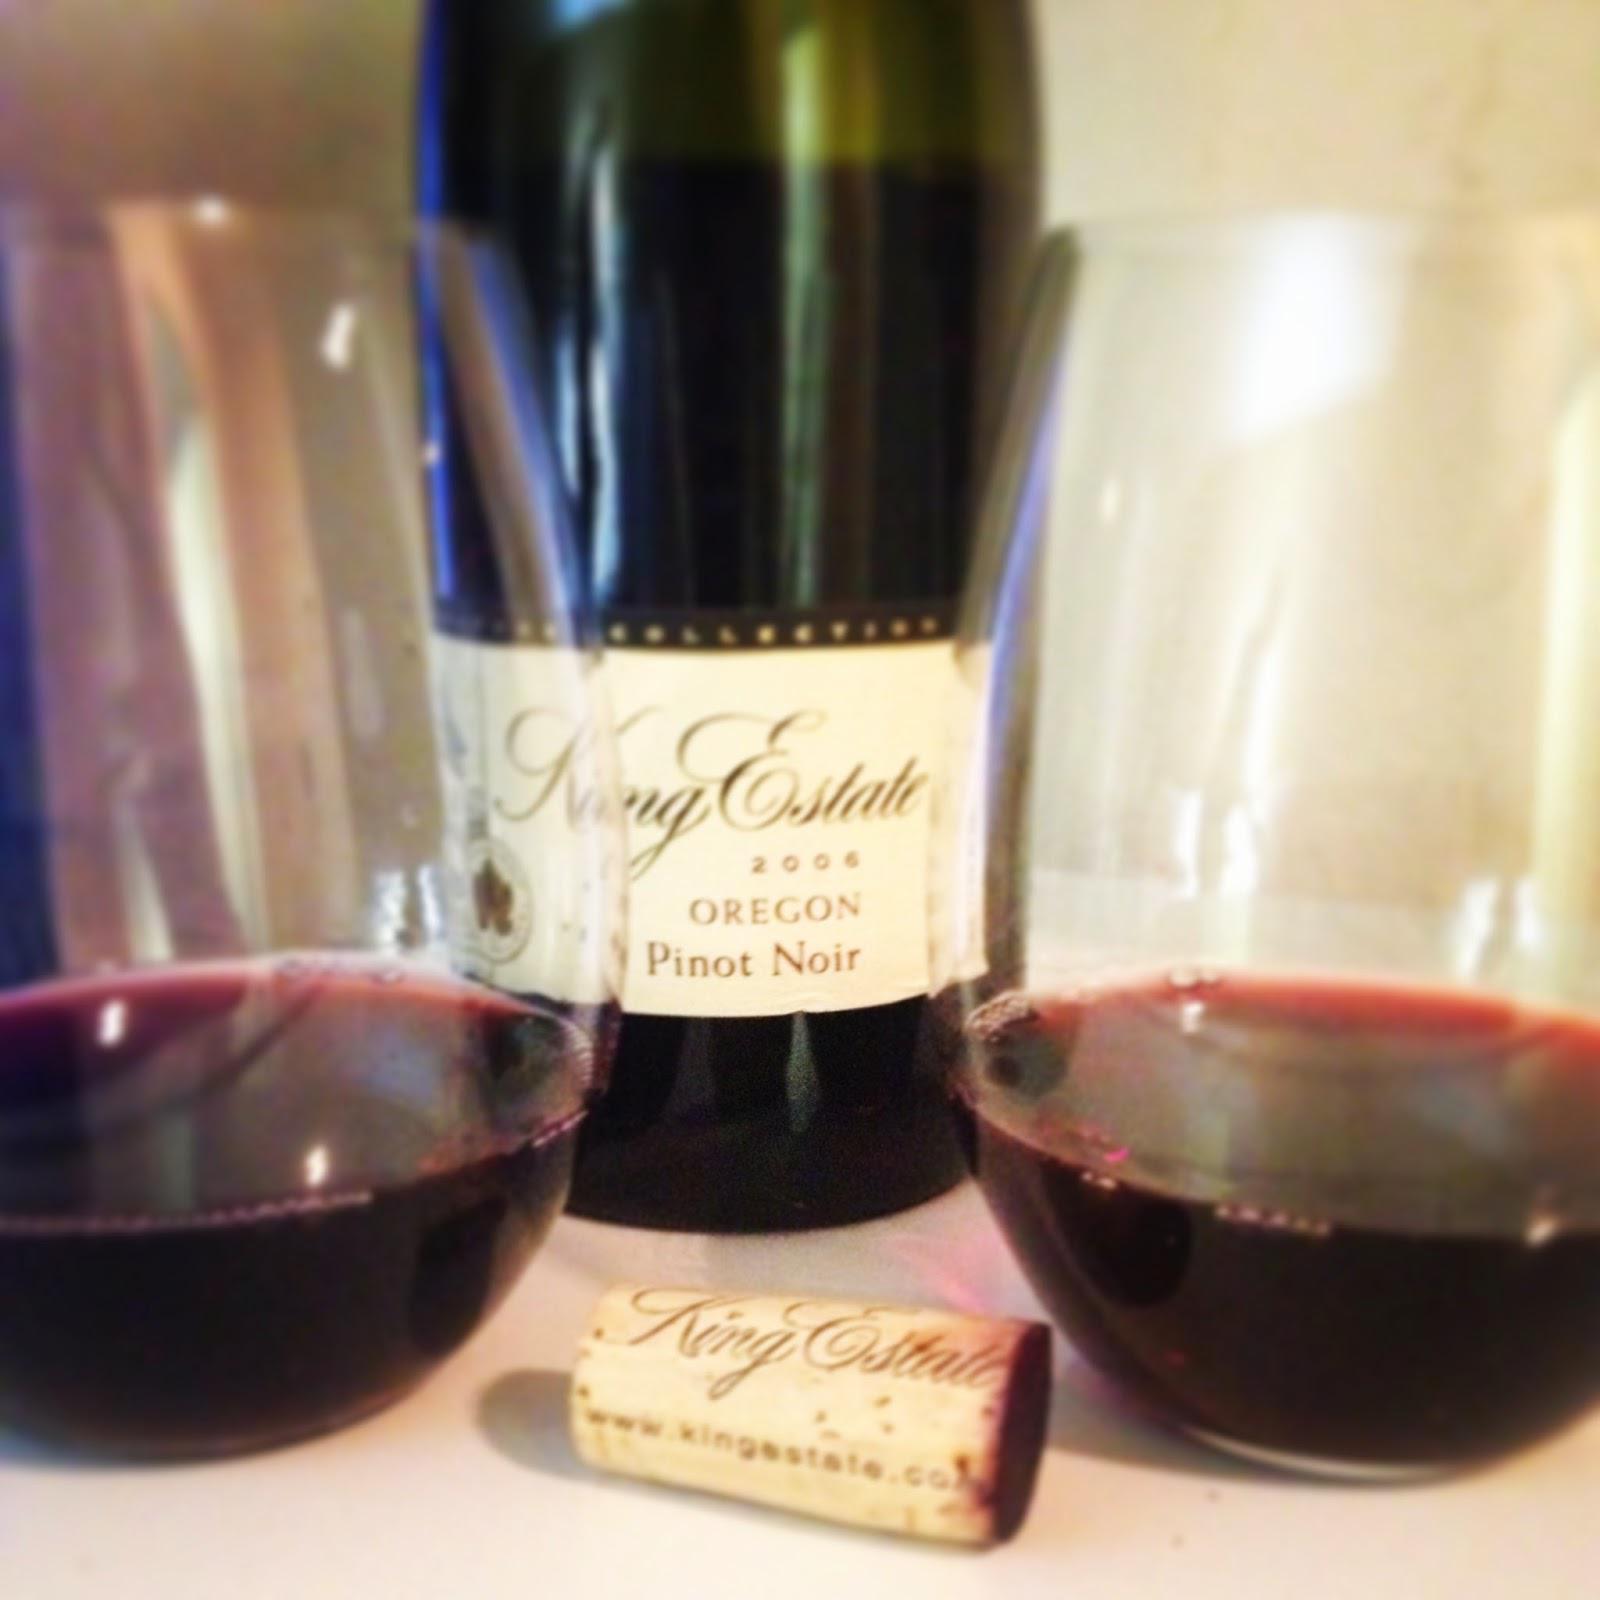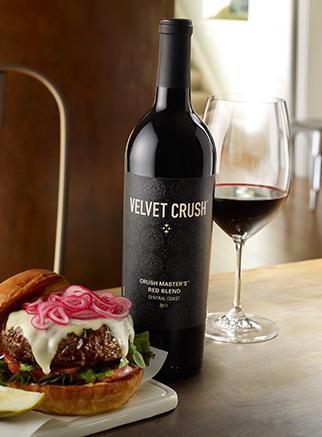The first image is the image on the left, the second image is the image on the right. For the images displayed, is the sentence "All pictures include at least one wine glass." factually correct? Answer yes or no. Yes. The first image is the image on the left, the second image is the image on the right. For the images shown, is this caption "A green wine bottle is to the right of a glass of wine in the right image." true? Answer yes or no. No. 